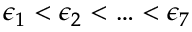Convert formula to latex. <formula><loc_0><loc_0><loc_500><loc_500>\epsilon _ { 1 } < \epsilon _ { 2 } < \dots < \epsilon _ { 7 }</formula> 